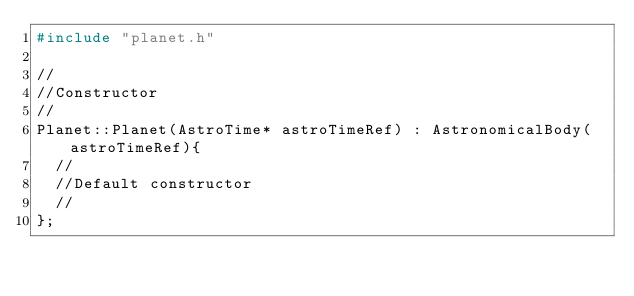Convert code to text. <code><loc_0><loc_0><loc_500><loc_500><_C++_>#include "planet.h"

//
//Constructor
//
Planet::Planet(AstroTime* astroTimeRef) : AstronomicalBody(astroTimeRef){
  //
  //Default constructor
  //
};
</code> 